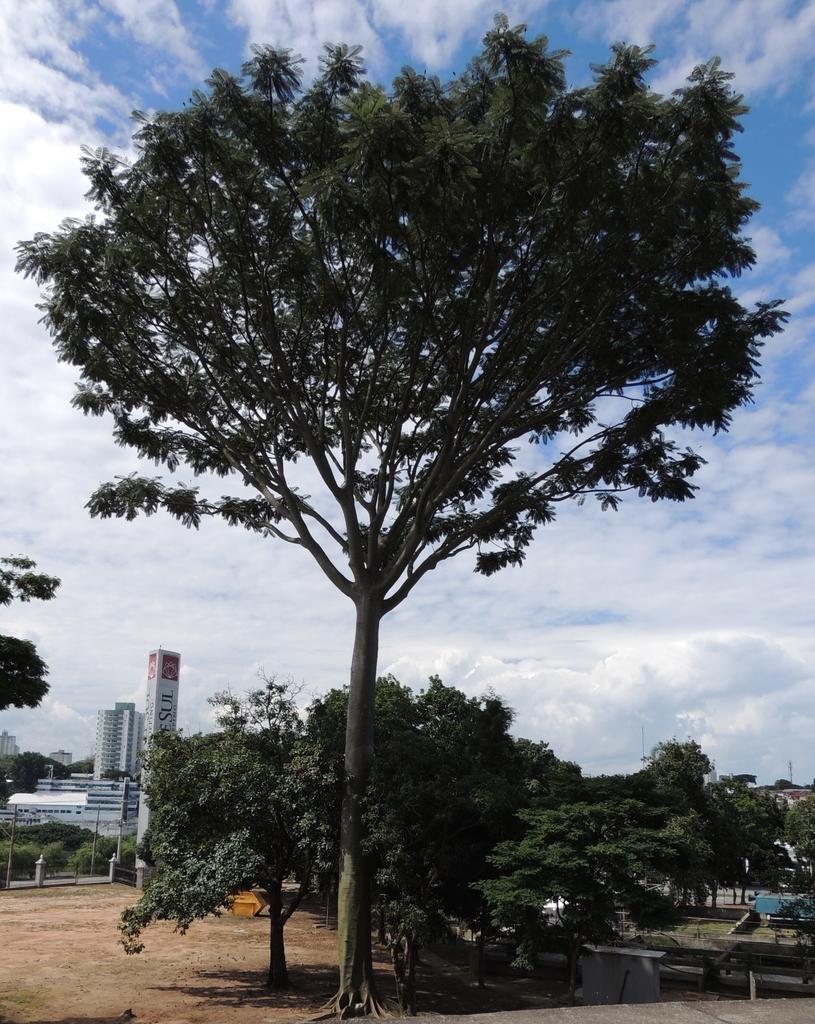In one or two sentences, can you explain what this image depicts? In the center of the image there are trees and in the background there are some buildings and also soil. There is sky with full of clouds. 